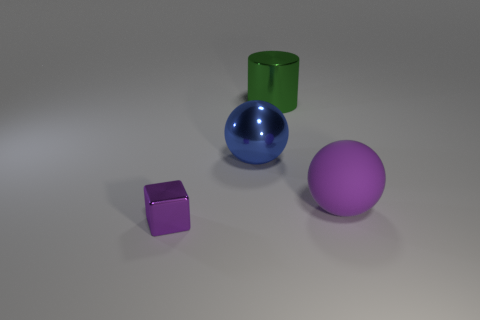Is there anything else that is the same shape as the large green object?
Keep it short and to the point. No. There is a metallic cube that is left of the large object that is on the left side of the large green metal cylinder; how many balls are in front of it?
Your answer should be very brief. 0. There is a ball that is made of the same material as the tiny purple thing; what size is it?
Ensure brevity in your answer.  Large. What number of large rubber spheres are the same color as the metallic block?
Provide a succinct answer. 1. Do the thing that is to the right of the metal cylinder and the purple metal cube have the same size?
Keep it short and to the point. No. What is the color of the object that is both right of the blue ball and in front of the large blue metallic object?
Your answer should be very brief. Purple. How many things are blocks or shiny objects that are behind the tiny purple metal block?
Provide a succinct answer. 3. What is the sphere behind the purple object behind the small cube in front of the blue shiny ball made of?
Offer a very short reply. Metal. Is there anything else that has the same material as the large purple sphere?
Your answer should be very brief. No. Does the metal thing that is in front of the big blue sphere have the same color as the matte object?
Make the answer very short. Yes. 